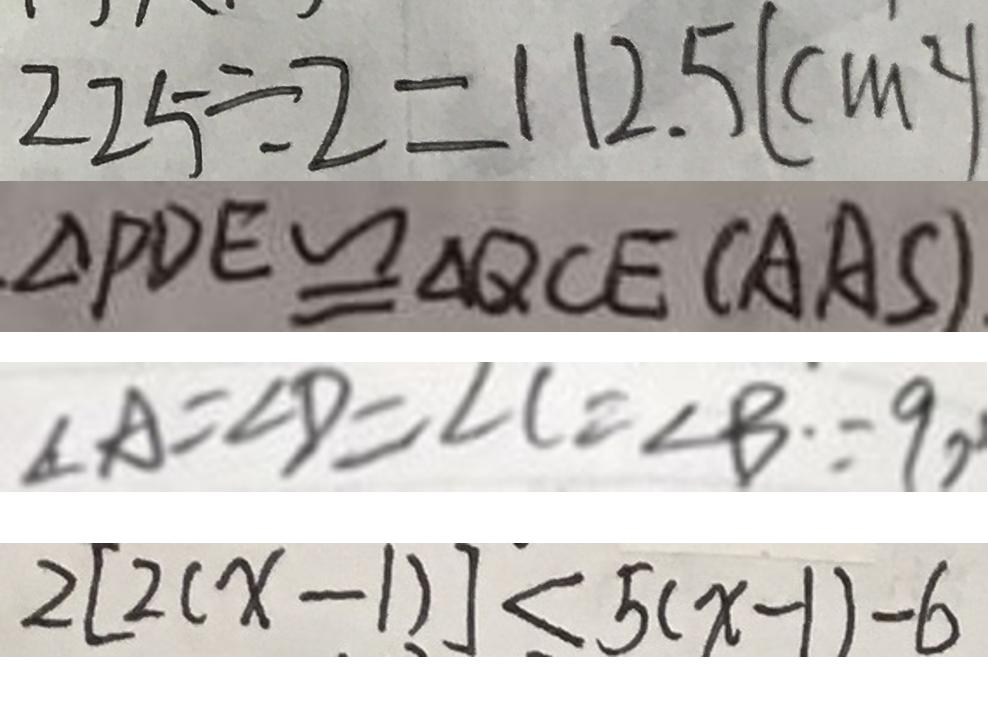<formula> <loc_0><loc_0><loc_500><loc_500>2 2 5 \div 2 = 1 1 2 . 5 ( c m ^ { 2 } ) 
 \Delta P D E \cong \Delta Q C E ( A A S ) 
 \angle A = \angle D = \angle C = \angle B \because 9 0 
 2 [ 2 ( x - 1 ) ] < 5 ( x - 1 ) - 6</formula> 